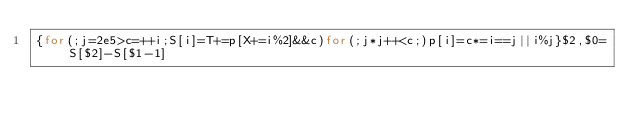<code> <loc_0><loc_0><loc_500><loc_500><_Awk_>{for(;j=2e5>c=++i;S[i]=T+=p[X+=i%2]&&c)for(;j*j++<c;)p[i]=c*=i==j||i%j}$2,$0=S[$2]-S[$1-1]</code> 